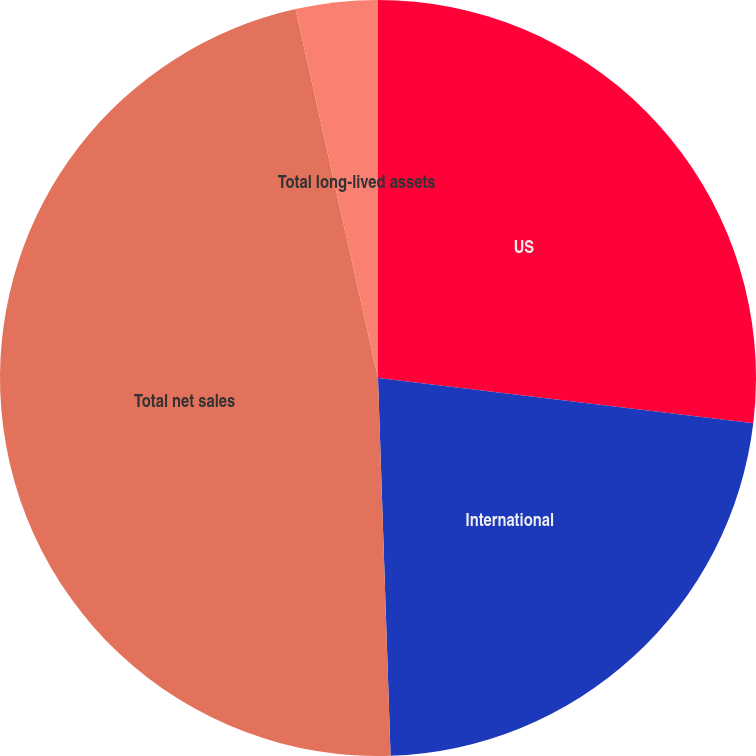<chart> <loc_0><loc_0><loc_500><loc_500><pie_chart><fcel>US<fcel>International<fcel>Total net sales<fcel>Total long-lived assets<nl><fcel>26.91%<fcel>22.56%<fcel>47.03%<fcel>3.5%<nl></chart> 